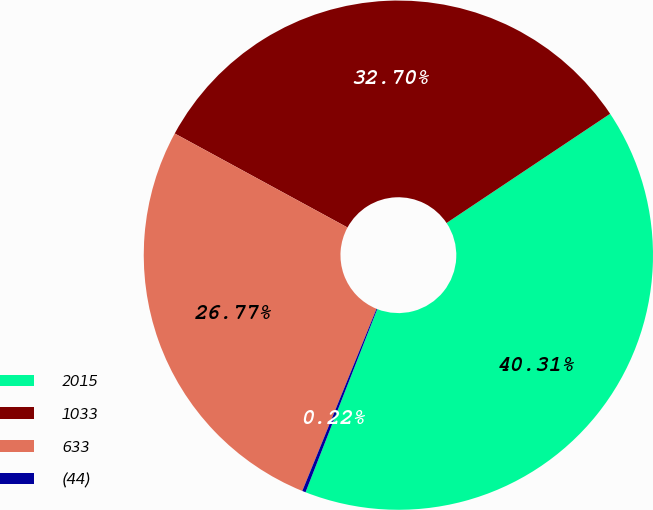Convert chart to OTSL. <chart><loc_0><loc_0><loc_500><loc_500><pie_chart><fcel>2015<fcel>1033<fcel>633<fcel>(44)<nl><fcel>40.31%<fcel>32.7%<fcel>26.77%<fcel>0.22%<nl></chart> 